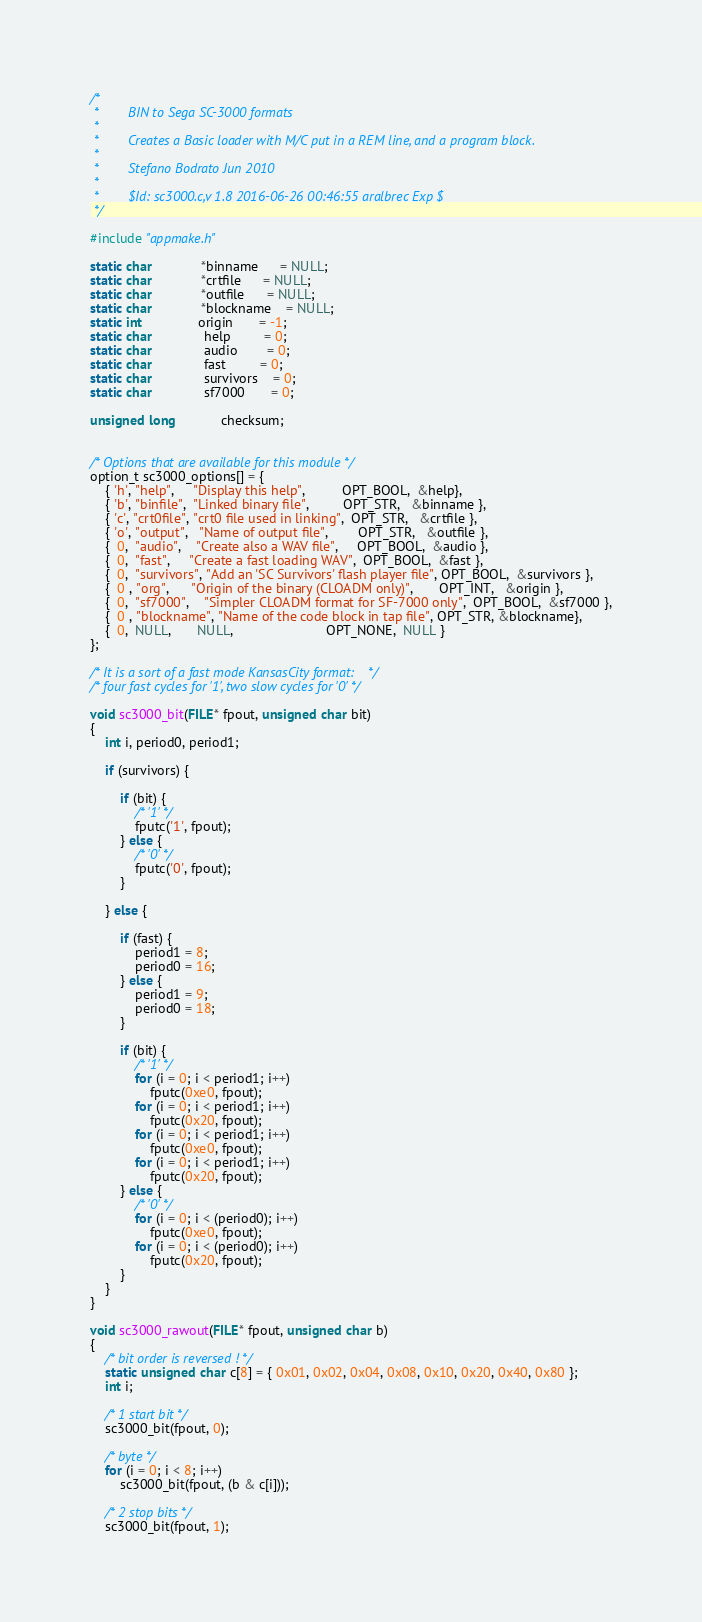Convert code to text. <code><loc_0><loc_0><loc_500><loc_500><_C_>/*
 *        BIN to Sega SC-3000 formats
 *
 *        Creates a Basic loader with M/C put in a REM line, and a program block.
 *
 *        Stefano Bodrato Jun 2010
 *
 *        $Id: sc3000.c,v 1.8 2016-06-26 00:46:55 aralbrec Exp $
 */

#include "appmake.h"

static char             *binname      = NULL;
static char             *crtfile      = NULL;
static char             *outfile      = NULL;
static char             *blockname    = NULL;
static int               origin       = -1;
static char              help         = 0;
static char              audio        = 0;
static char              fast         = 0;
static char              survivors    = 0;
static char              sf7000       = 0;

unsigned long            checksum;


/* Options that are available for this module */
option_t sc3000_options[] = {
    { 'h', "help",     "Display this help",          OPT_BOOL,  &help},
    { 'b', "binfile",  "Linked binary file",         OPT_STR,   &binname },
    { 'c', "crt0file", "crt0 file used in linking",  OPT_STR,   &crtfile },
    { 'o', "output",   "Name of output file",        OPT_STR,   &outfile },
    {  0,  "audio",    "Create also a WAV file",     OPT_BOOL,  &audio },
    {  0,  "fast",     "Create a fast loading WAV",  OPT_BOOL,  &fast },
    {  0,  "survivors", "Add an 'SC Survivors' flash player file", OPT_BOOL,  &survivors },
    {  0 , "org",      "Origin of the binary (CLOADM only)",       OPT_INT,   &origin },
    {  0,  "sf7000",    "Simpler CLOADM format for SF-7000 only",  OPT_BOOL,  &sf7000 },
    {  0 , "blockname", "Name of the code block in tap file", OPT_STR, &blockname},
    {  0,  NULL,       NULL,                         OPT_NONE,  NULL }
};

/* It is a sort of a fast mode KansasCity format:    */
/* four fast cycles for '1', two slow cycles for '0' */

void sc3000_bit(FILE* fpout, unsigned char bit)
{
    int i, period0, period1;

    if (survivors) {

        if (bit) {
            /* '1' */
            fputc('1', fpout);
        } else {
            /* '0' */
            fputc('0', fpout);
        }

    } else {

        if (fast) {
            period1 = 8;
            period0 = 16;
        } else {
            period1 = 9;
            period0 = 18;
        }

        if (bit) {
            /* '1' */
            for (i = 0; i < period1; i++)
                fputc(0xe0, fpout);
            for (i = 0; i < period1; i++)
                fputc(0x20, fpout);
            for (i = 0; i < period1; i++)
                fputc(0xe0, fpout);
            for (i = 0; i < period1; i++)
                fputc(0x20, fpout);
        } else {
            /* '0' */
            for (i = 0; i < (period0); i++)
                fputc(0xe0, fpout);
            for (i = 0; i < (period0); i++)
                fputc(0x20, fpout);
        }
    }
}

void sc3000_rawout(FILE* fpout, unsigned char b)
{
    /* bit order is reversed ! */
    static unsigned char c[8] = { 0x01, 0x02, 0x04, 0x08, 0x10, 0x20, 0x40, 0x80 };
    int i;

    /* 1 start bit */
    sc3000_bit(fpout, 0);

    /* byte */
    for (i = 0; i < 8; i++)
        sc3000_bit(fpout, (b & c[i]));

    /* 2 stop bits */
    sc3000_bit(fpout, 1);</code> 